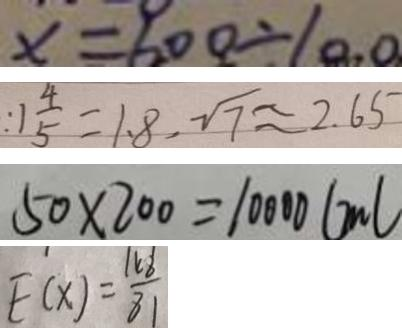<formula> <loc_0><loc_0><loc_500><loc_500>x = 6 0 0 \div 1 0 . 0 
 : 1 \frac { 4 } { 5 } = 1 . 8 , \sqrt { 7 } \approx 2 . 6 5 
 5 0 \times 2 0 0 = 1 0 0 0 0 ( m l 
 E ( x ) = \frac { 1 6 8 } { 8 1 }</formula> 